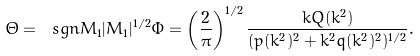<formula> <loc_0><loc_0><loc_500><loc_500>\Theta = \ s g n M _ { 1 } | M _ { 1 } | ^ { 1 / 2 } \Phi = \left ( \frac { 2 } { \pi } \right ) ^ { 1 / 2 } \frac { k Q ( k ^ { 2 } ) } { ( p ( k ^ { 2 } ) ^ { 2 } + k ^ { 2 } q ( k ^ { 2 } ) ^ { 2 } ) ^ { 1 / 2 } } .</formula> 